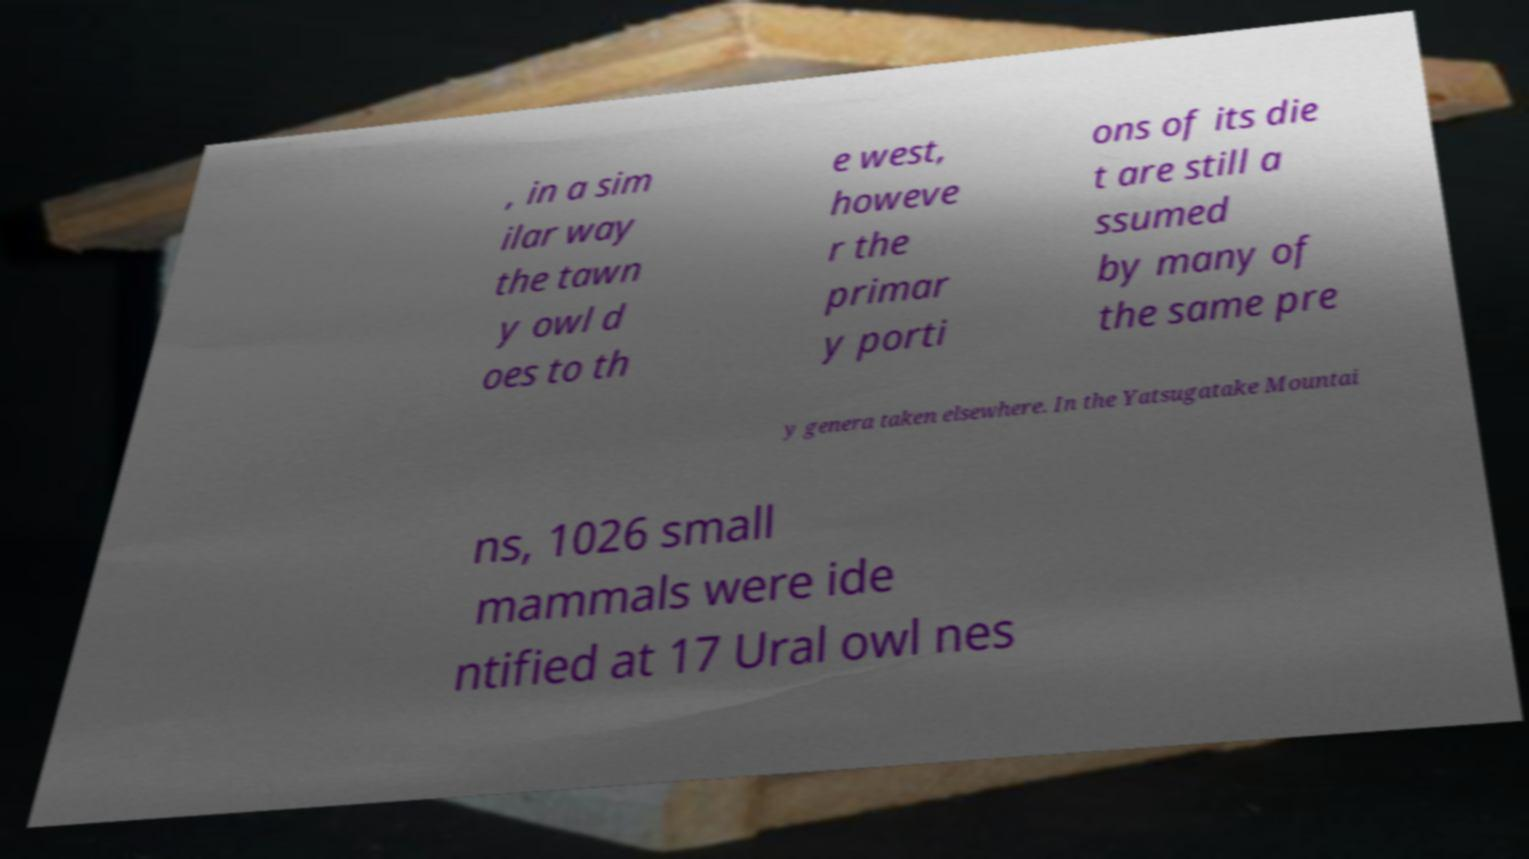Please read and relay the text visible in this image. What does it say? , in a sim ilar way the tawn y owl d oes to th e west, howeve r the primar y porti ons of its die t are still a ssumed by many of the same pre y genera taken elsewhere. In the Yatsugatake Mountai ns, 1026 small mammals were ide ntified at 17 Ural owl nes 